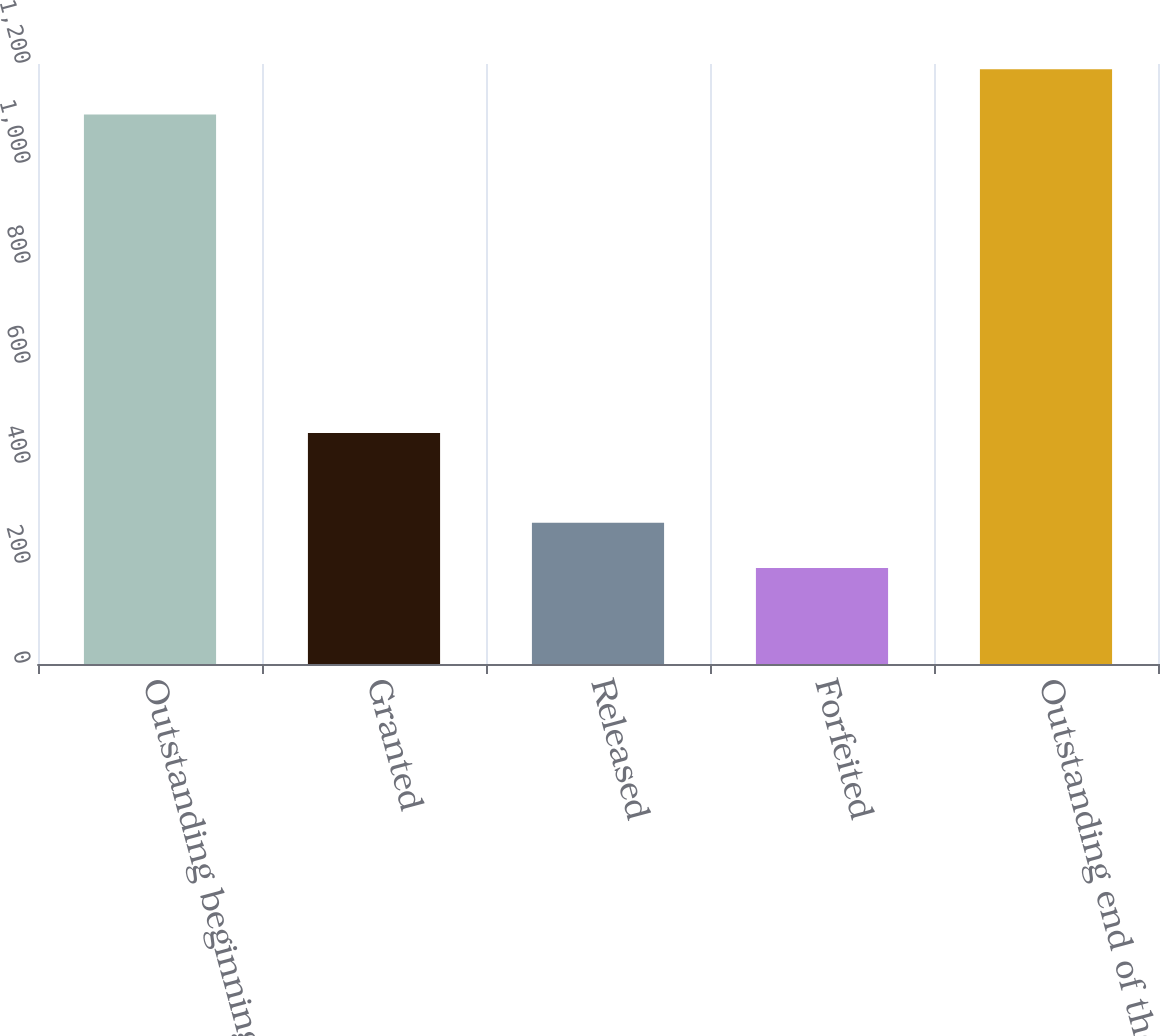Convert chart to OTSL. <chart><loc_0><loc_0><loc_500><loc_500><bar_chart><fcel>Outstanding beginning of the<fcel>Granted<fcel>Released<fcel>Forfeited<fcel>Outstanding end of the year<nl><fcel>1099<fcel>462<fcel>282.7<fcel>192<fcel>1189.7<nl></chart> 